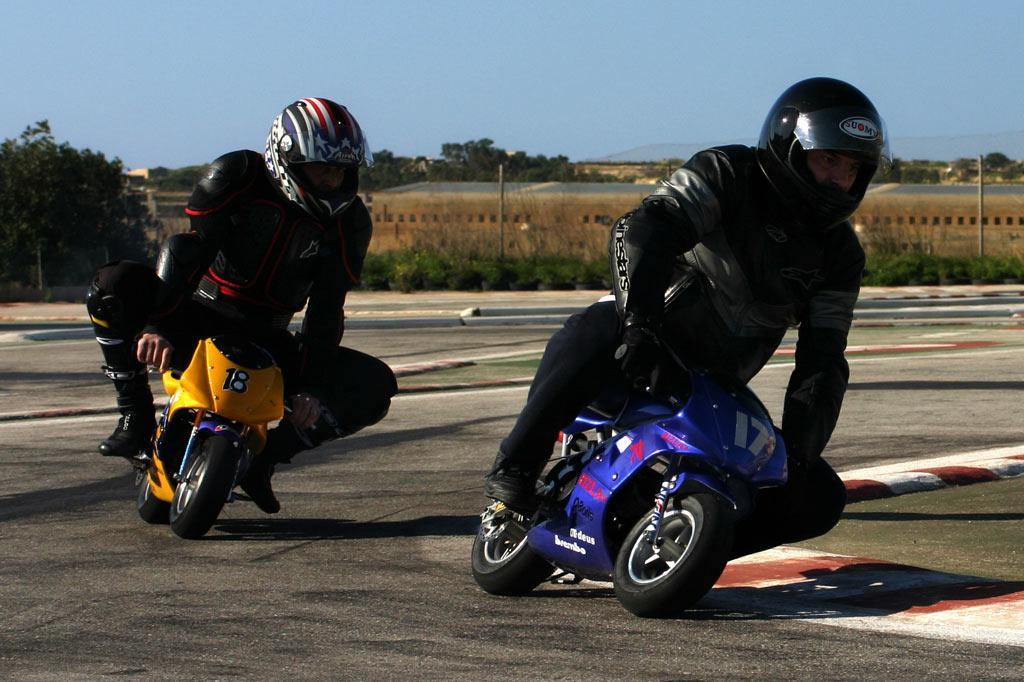How many men are in the image? There are two men in the foreground of the image. What are the men wearing? The men are wearing black jackets. What are the men doing in the image? The men are riding small bikes on the road. What can be seen in the background of the image? There are trees, poles, a shed, plants, and the sky visible in the background of the image. What type of powder can be seen falling from the sky in the image? There is no powder falling from the sky in the image; the sky is visible but no such substance is present. 